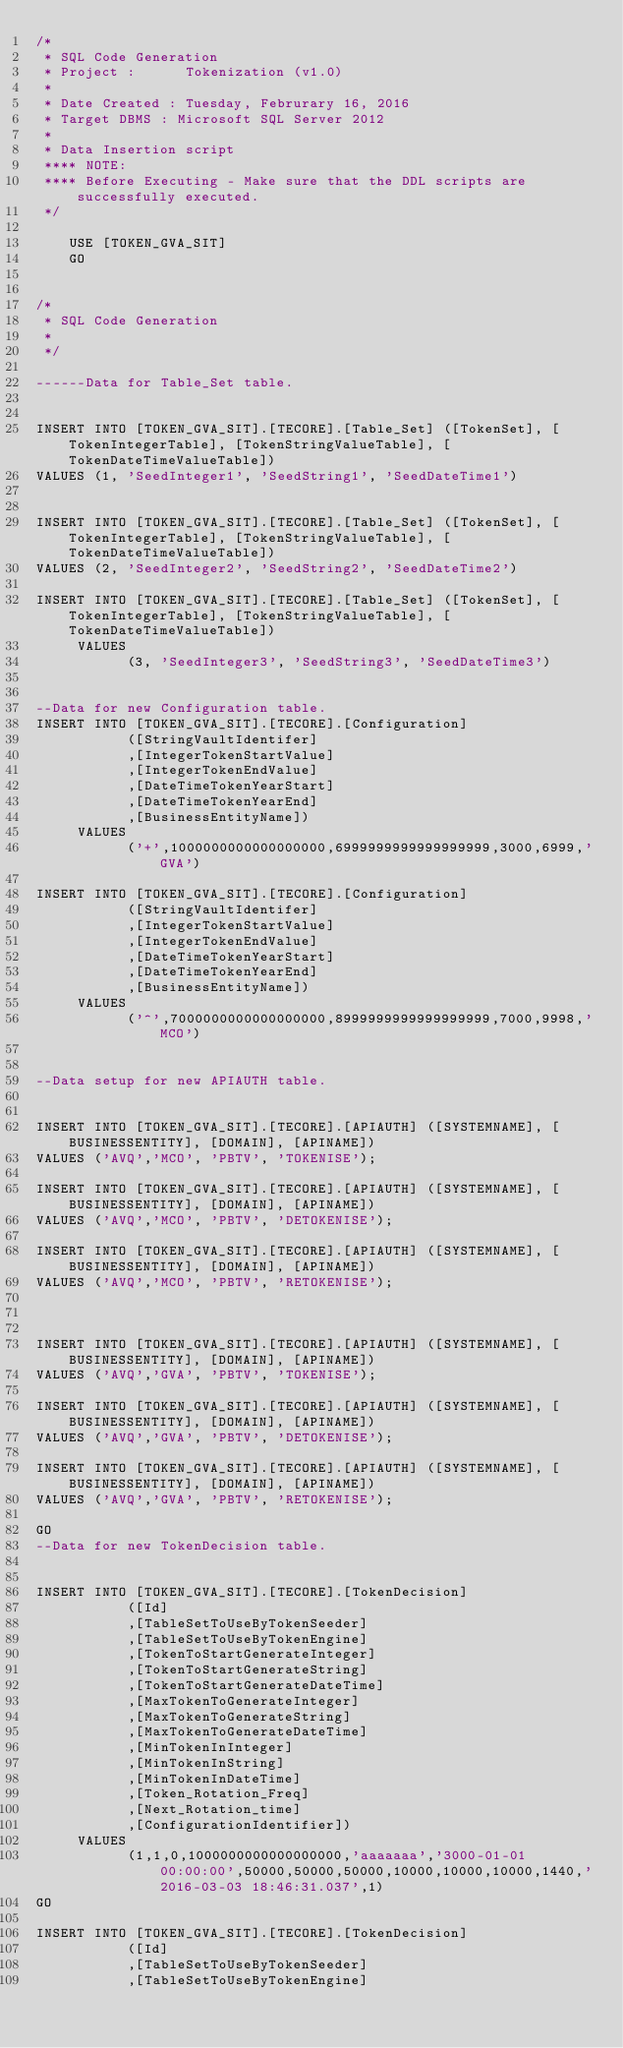Convert code to text. <code><loc_0><loc_0><loc_500><loc_500><_SQL_>/*
 * SQL Code Generation
 * Project :      Tokenization (v1.0)
 *
 * Date Created : Tuesday, Februrary 16, 2016 
 * Target DBMS : Microsoft SQL Server 2012
 *
 * Data Insertion script 
 **** NOTE:
 **** Before Executing - Make sure that the DDL scripts are successfully executed.
 */
 
	USE [TOKEN_GVA_SIT]
	GO


/*
 * SQL Code Generation 
 *
 */
	   
------Data for Table_Set table.


INSERT INTO [TOKEN_GVA_SIT].[TECORE].[Table_Set] ([TokenSet], [TokenIntegerTable], [TokenStringValueTable], [TokenDateTimeValueTable])
VALUES (1, 'SeedInteger1', 'SeedString1', 'SeedDateTime1')


INSERT INTO [TOKEN_GVA_SIT].[TECORE].[Table_Set] ([TokenSet], [TokenIntegerTable], [TokenStringValueTable], [TokenDateTimeValueTable])
VALUES (2, 'SeedInteger2', 'SeedString2', 'SeedDateTime2')

INSERT INTO [TOKEN_GVA_SIT].[TECORE].[Table_Set] ([TokenSet], [TokenIntegerTable], [TokenStringValueTable], [TokenDateTimeValueTable])
     VALUES
           (3, 'SeedInteger3', 'SeedString3', 'SeedDateTime3')


--Data for new Configuration table.
INSERT INTO [TOKEN_GVA_SIT].[TECORE].[Configuration]
           ([StringVaultIdentifer]
           ,[IntegerTokenStartValue]
           ,[IntegerTokenEndValue]
           ,[DateTimeTokenYearStart]
           ,[DateTimeTokenYearEnd]
           ,[BusinessEntityName])
     VALUES
           ('+',1000000000000000000,6999999999999999999,3000,6999,'GVA')

INSERT INTO [TOKEN_GVA_SIT].[TECORE].[Configuration]
           ([StringVaultIdentifer]
           ,[IntegerTokenStartValue]
           ,[IntegerTokenEndValue]
           ,[DateTimeTokenYearStart]
           ,[DateTimeTokenYearEnd]
           ,[BusinessEntityName])
     VALUES
           ('^',7000000000000000000,8999999999999999999,7000,9998,'MCO')
       
 
--Data setup for new APIAUTH table.


INSERT INTO [TOKEN_GVA_SIT].[TECORE].[APIAUTH] ([SYSTEMNAME], [BUSINESSENTITY], [DOMAIN], [APINAME]) 
VALUES ('AVQ','MCO', 'PBTV', 'TOKENISE');

INSERT INTO [TOKEN_GVA_SIT].[TECORE].[APIAUTH] ([SYSTEMNAME], [BUSINESSENTITY], [DOMAIN], [APINAME]) 
VALUES ('AVQ','MCO', 'PBTV', 'DETOKENISE');

INSERT INTO [TOKEN_GVA_SIT].[TECORE].[APIAUTH] ([SYSTEMNAME], [BUSINESSENTITY], [DOMAIN], [APINAME]) 
VALUES ('AVQ','MCO', 'PBTV', 'RETOKENISE');



INSERT INTO [TOKEN_GVA_SIT].[TECORE].[APIAUTH] ([SYSTEMNAME], [BUSINESSENTITY], [DOMAIN], [APINAME]) 
VALUES ('AVQ','GVA', 'PBTV', 'TOKENISE');

INSERT INTO [TOKEN_GVA_SIT].[TECORE].[APIAUTH] ([SYSTEMNAME], [BUSINESSENTITY], [DOMAIN], [APINAME]) 
VALUES ('AVQ','GVA', 'PBTV', 'DETOKENISE');

INSERT INTO [TOKEN_GVA_SIT].[TECORE].[APIAUTH] ([SYSTEMNAME], [BUSINESSENTITY], [DOMAIN], [APINAME]) 
VALUES ('AVQ','GVA', 'PBTV', 'RETOKENISE');

GO
--Data for new TokenDecision table.


INSERT INTO [TOKEN_GVA_SIT].[TECORE].[TokenDecision]
           ([Id]
           ,[TableSetToUseByTokenSeeder]
           ,[TableSetToUseByTokenEngine]
           ,[TokenToStartGenerateInteger]
           ,[TokenToStartGenerateString]
           ,[TokenToStartGenerateDateTime]
           ,[MaxTokenToGenerateInteger]
           ,[MaxTokenToGenerateString]
           ,[MaxTokenToGenerateDateTime]
           ,[MinTokenInInteger]
           ,[MinTokenInString]
           ,[MinTokenInDateTime]
           ,[Token_Rotation_Freq]
           ,[Next_Rotation_time]
           ,[ConfigurationIdentifier])
     VALUES
           (1,1,0,1000000000000000000,'aaaaaaa','3000-01-01 00:00:00',50000,50000,50000,10000,10000,10000,1440,'2016-03-03 18:46:31.037',1)
GO

INSERT INTO [TOKEN_GVA_SIT].[TECORE].[TokenDecision]
           ([Id]
           ,[TableSetToUseByTokenSeeder]
           ,[TableSetToUseByTokenEngine]</code> 